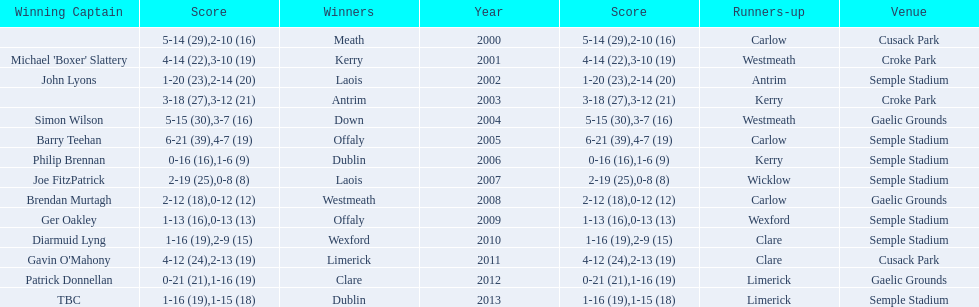Who was the first winning captain? Michael 'Boxer' Slattery. 